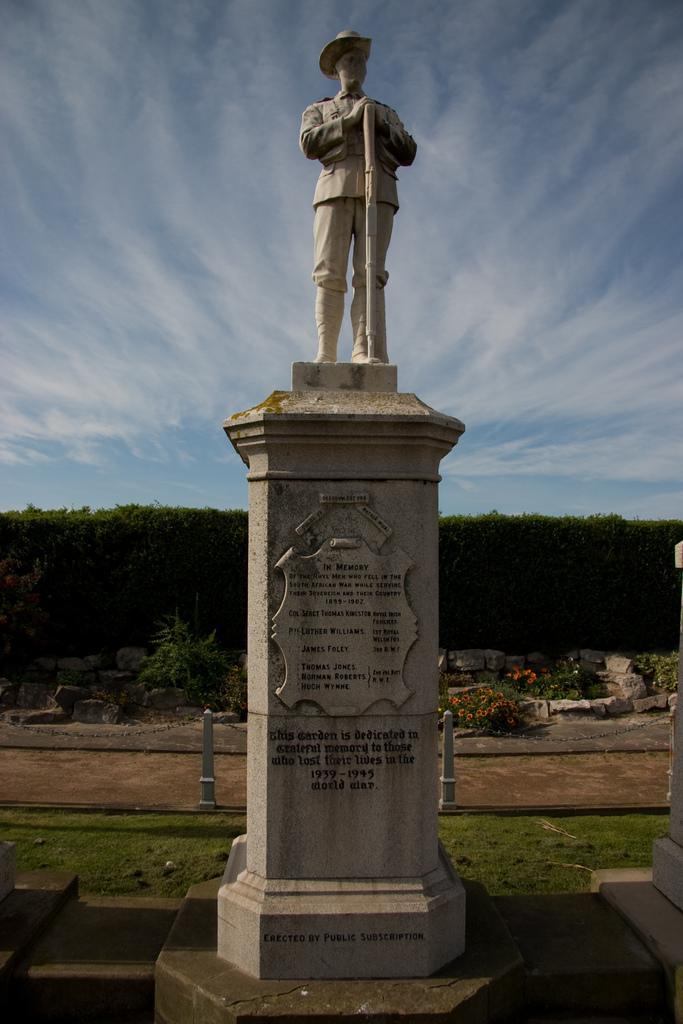Can you describe this image briefly? In this image in the center there is a pillar and on the top of the pillar there is a statue and on the pillar there is some text written on it. In the center there is grass on the ground and in the background there are trees and flowers and the sky is cloudy. 